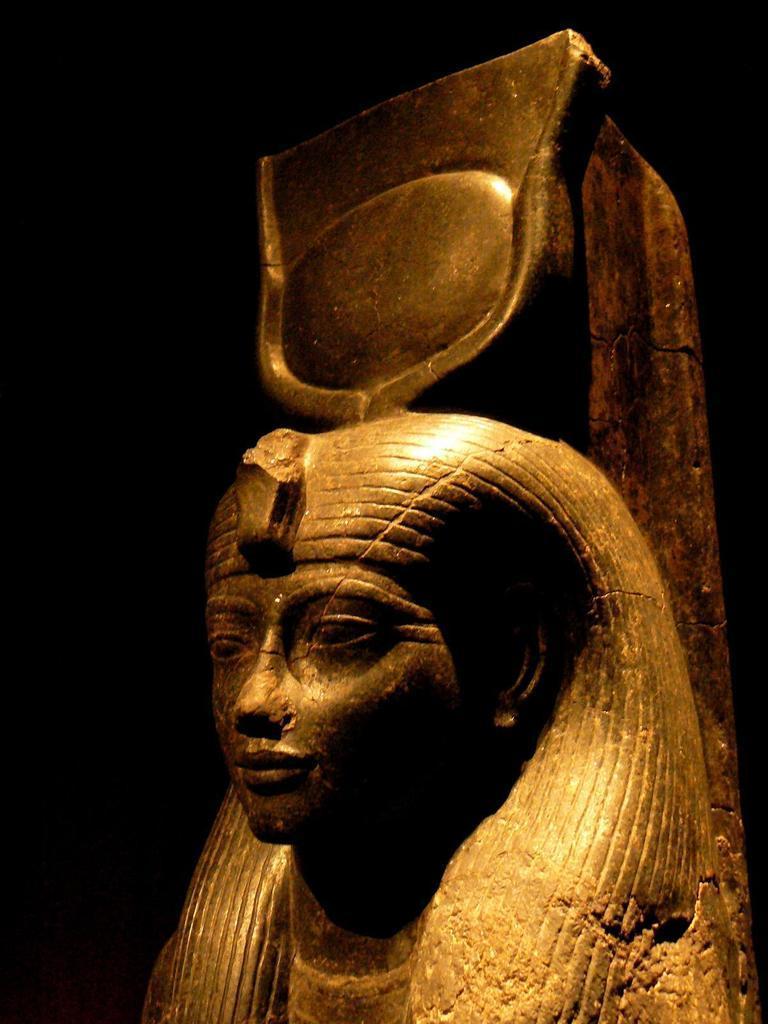Could you give a brief overview of what you see in this image? In this image in the front there is a statue. 